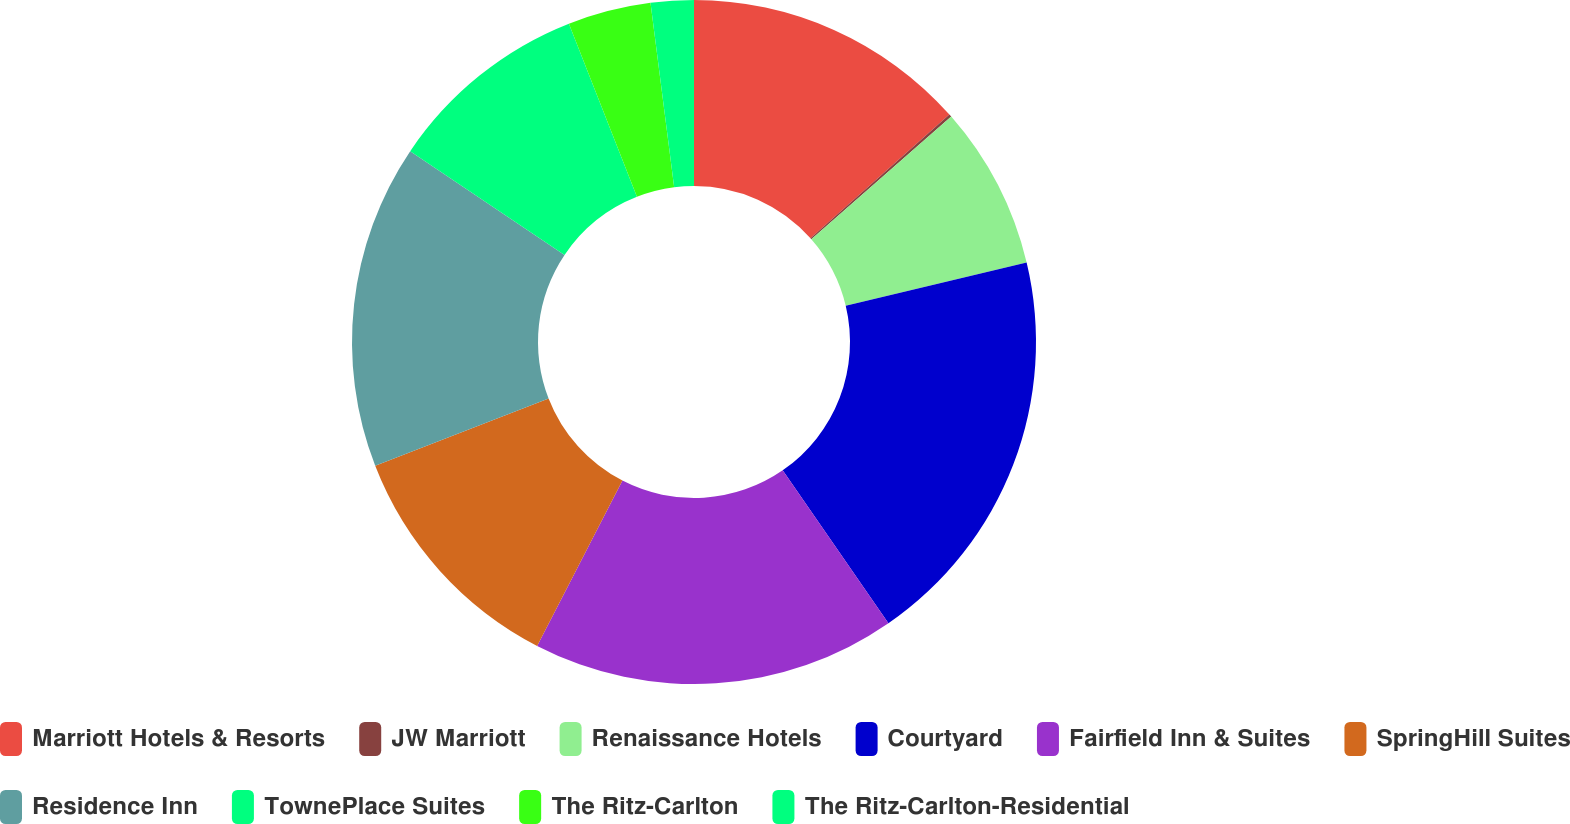<chart> <loc_0><loc_0><loc_500><loc_500><pie_chart><fcel>Marriott Hotels & Resorts<fcel>JW Marriott<fcel>Renaissance Hotels<fcel>Courtyard<fcel>Fairfield Inn & Suites<fcel>SpringHill Suites<fcel>Residence Inn<fcel>TownePlace Suites<fcel>The Ritz-Carlton<fcel>The Ritz-Carlton-Residential<nl><fcel>13.42%<fcel>0.13%<fcel>7.72%<fcel>19.11%<fcel>17.21%<fcel>11.52%<fcel>15.32%<fcel>9.62%<fcel>3.93%<fcel>2.03%<nl></chart> 